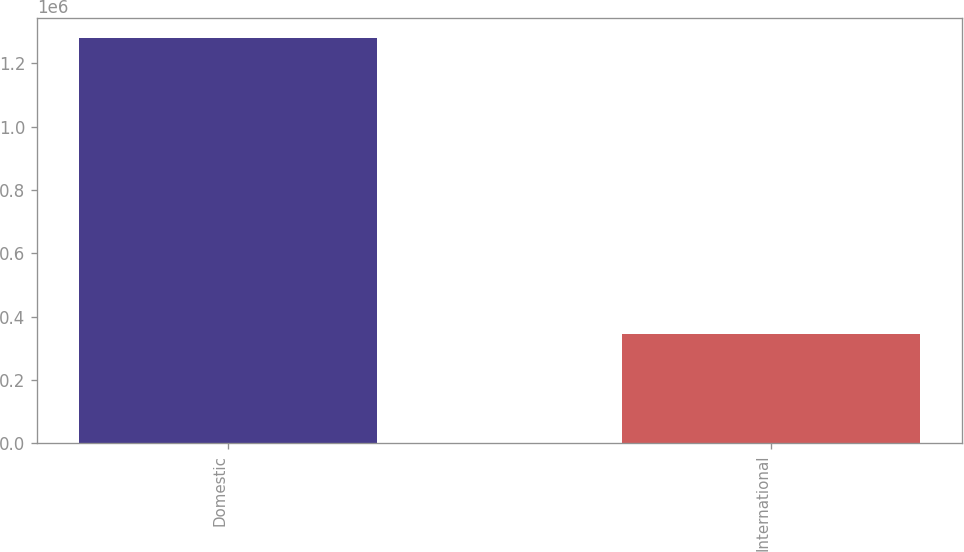Convert chart to OTSL. <chart><loc_0><loc_0><loc_500><loc_500><bar_chart><fcel>Domestic<fcel>International<nl><fcel>1.27875e+06<fcel>344351<nl></chart> 